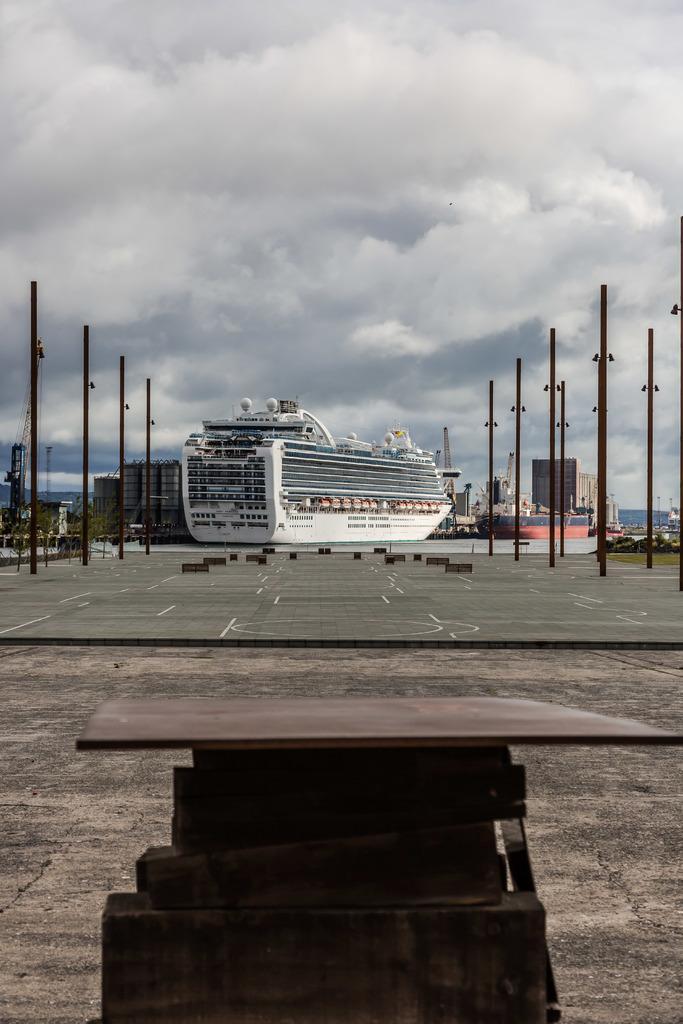Please provide a concise description of this image. In the background of the image there are boats, sky,clouds. In the center of the image there is road, poles. In the foreground of the image there is a wooden object. 